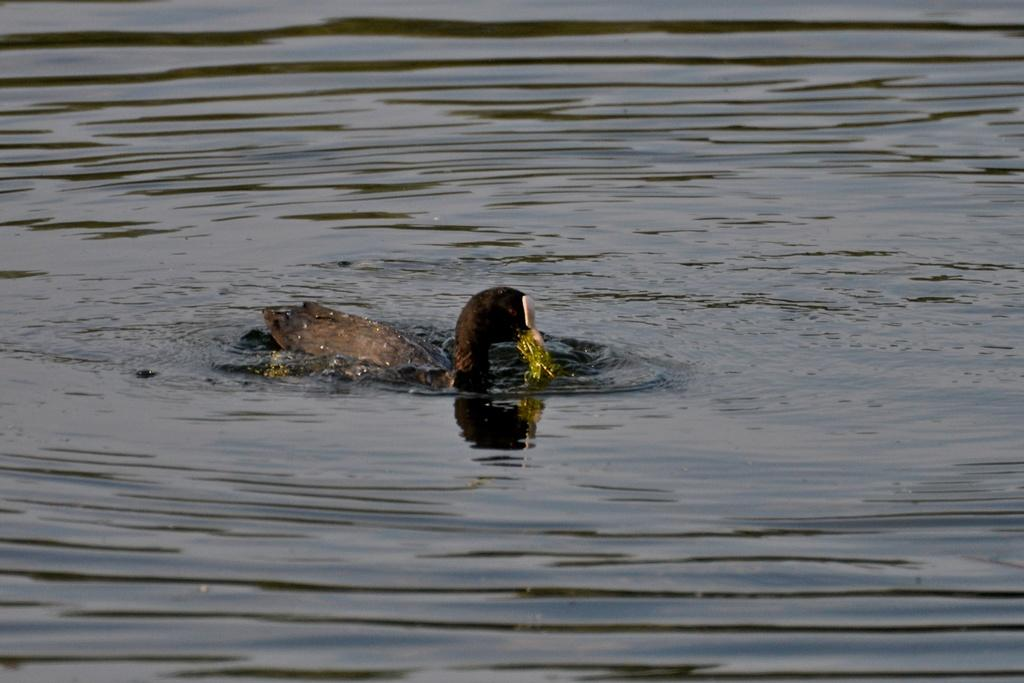What animal is present in the image? There is a duck in the image. What is the duck doing in the image? The duck is swimming on the water. What degree does the duck have in the image? The image does not provide information about the duck's educational background, so it cannot be determined. 